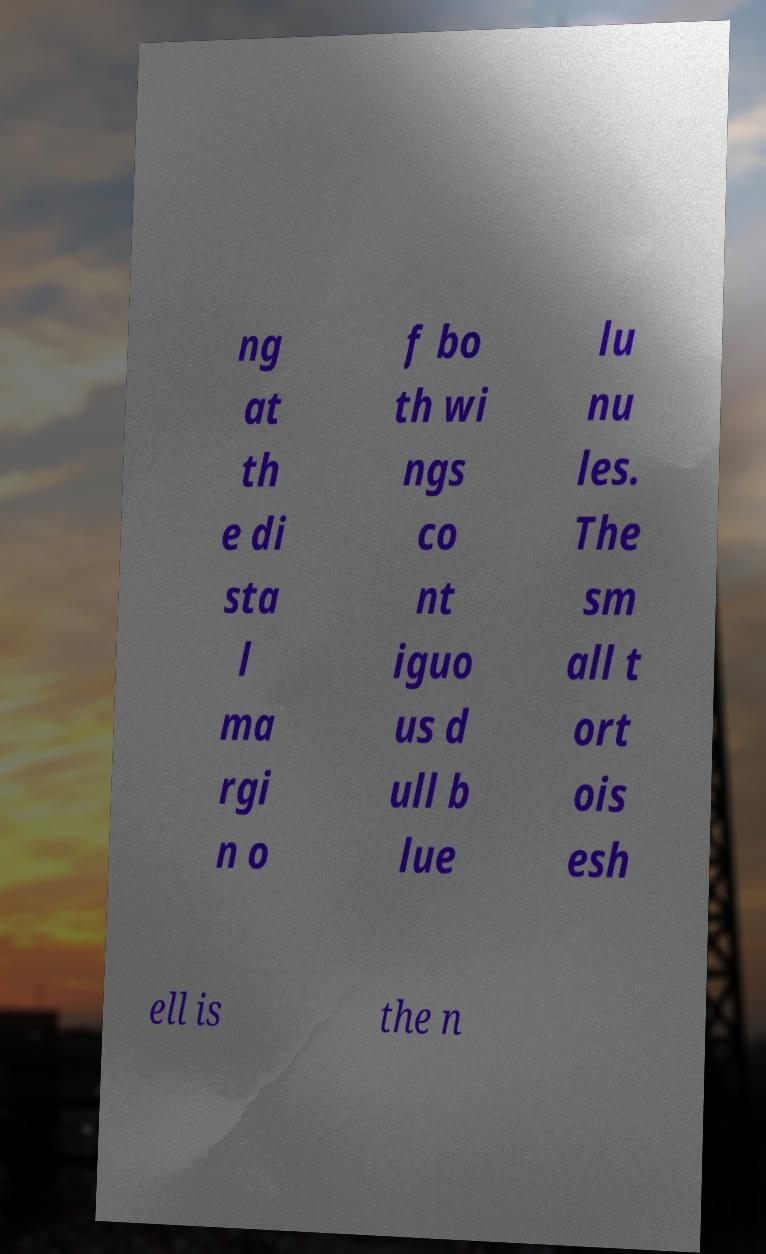Can you read and provide the text displayed in the image?This photo seems to have some interesting text. Can you extract and type it out for me? ng at th e di sta l ma rgi n o f bo th wi ngs co nt iguo us d ull b lue lu nu les. The sm all t ort ois esh ell is the n 